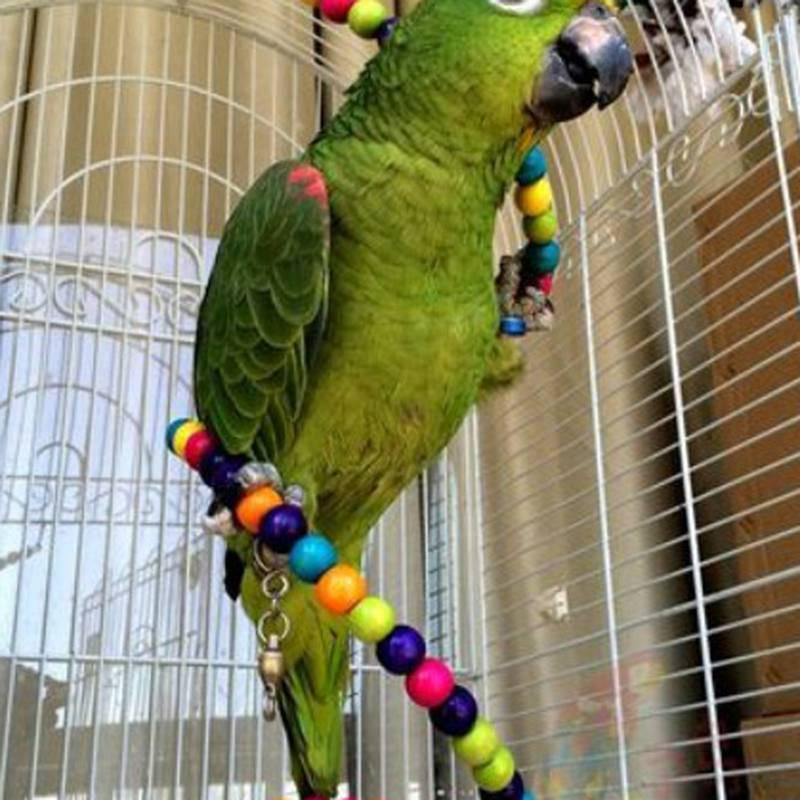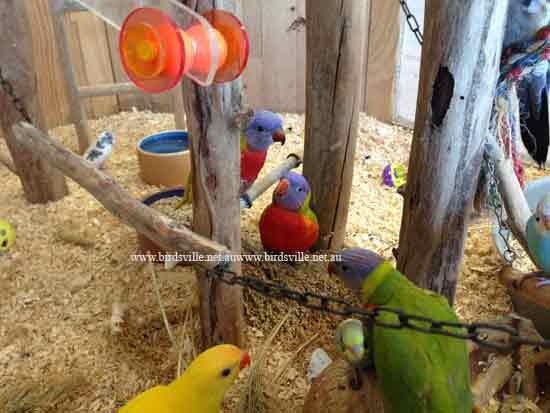The first image is the image on the left, the second image is the image on the right. Considering the images on both sides, is "A green bird is sitting in a cage in the image on the left." valid? Answer yes or no. Yes. The first image is the image on the left, the second image is the image on the right. Assess this claim about the two images: "Each image features at least one bird and a wire bird cage.". Correct or not? Answer yes or no. No. 